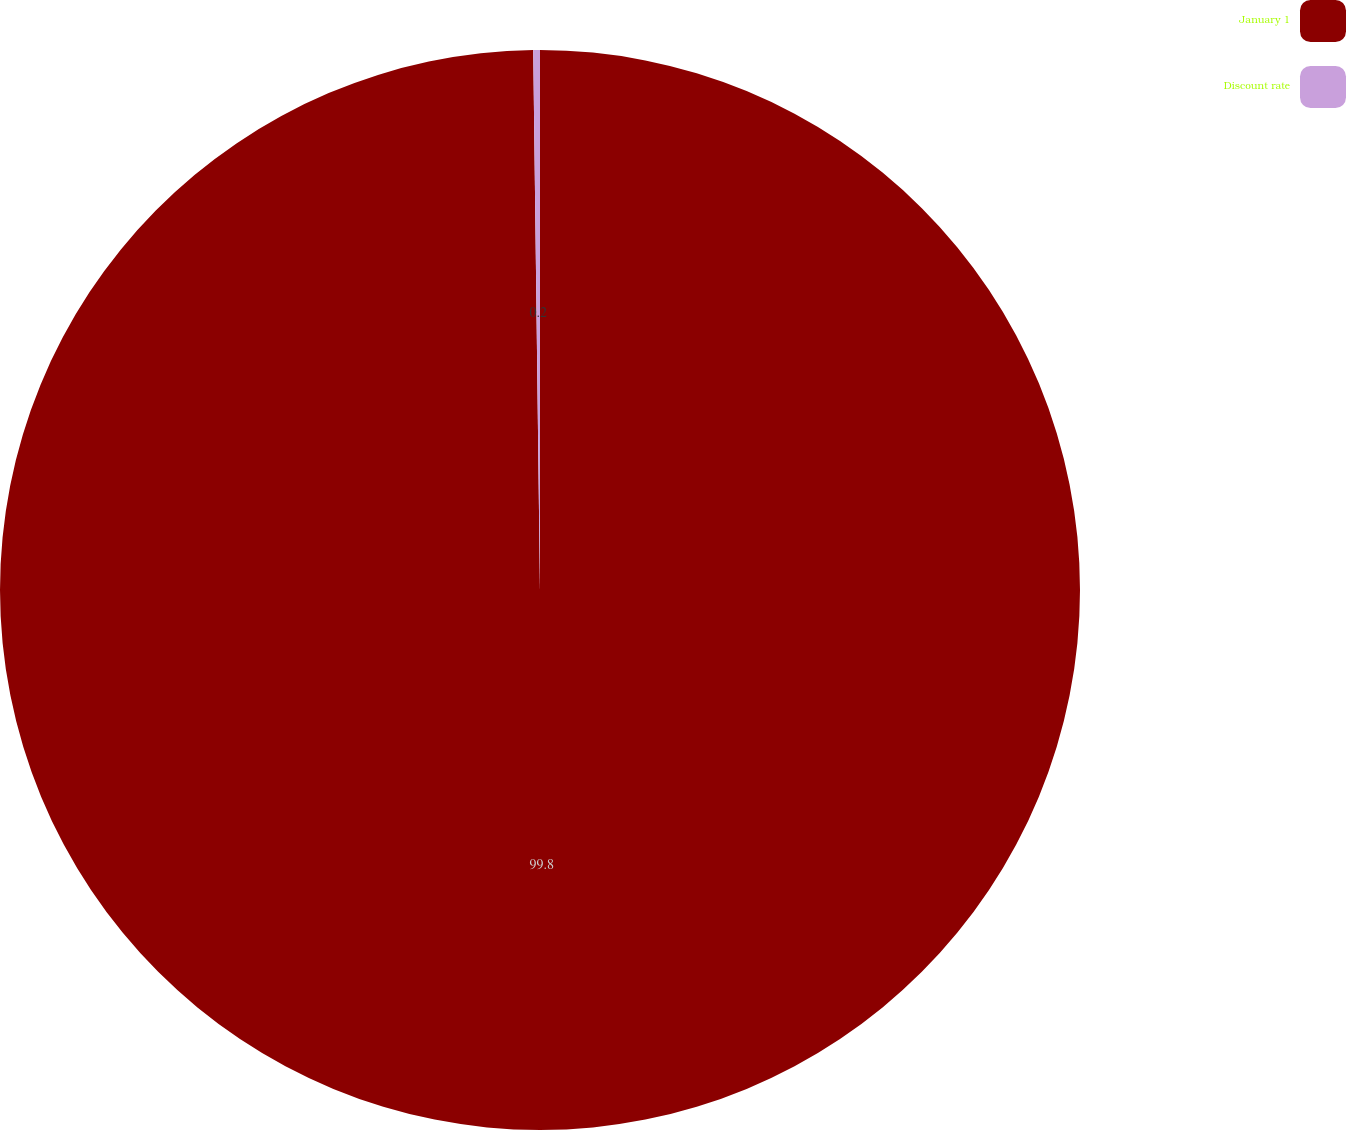Convert chart. <chart><loc_0><loc_0><loc_500><loc_500><pie_chart><fcel>January 1<fcel>Discount rate<nl><fcel>99.8%<fcel>0.2%<nl></chart> 